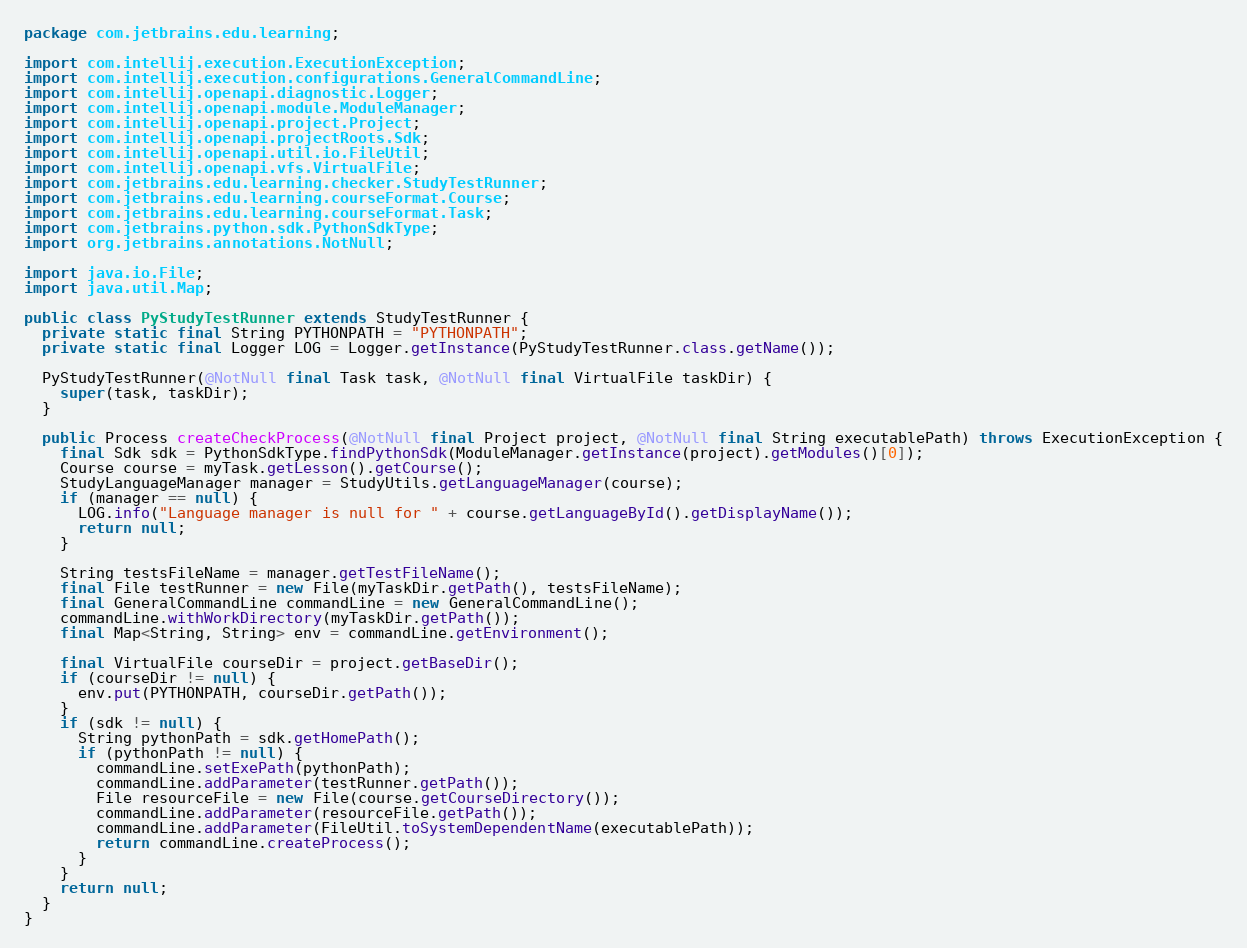<code> <loc_0><loc_0><loc_500><loc_500><_Java_>package com.jetbrains.edu.learning;

import com.intellij.execution.ExecutionException;
import com.intellij.execution.configurations.GeneralCommandLine;
import com.intellij.openapi.diagnostic.Logger;
import com.intellij.openapi.module.ModuleManager;
import com.intellij.openapi.project.Project;
import com.intellij.openapi.projectRoots.Sdk;
import com.intellij.openapi.util.io.FileUtil;
import com.intellij.openapi.vfs.VirtualFile;
import com.jetbrains.edu.learning.checker.StudyTestRunner;
import com.jetbrains.edu.learning.courseFormat.Course;
import com.jetbrains.edu.learning.courseFormat.Task;
import com.jetbrains.python.sdk.PythonSdkType;
import org.jetbrains.annotations.NotNull;

import java.io.File;
import java.util.Map;

public class PyStudyTestRunner extends StudyTestRunner {
  private static final String PYTHONPATH = "PYTHONPATH";
  private static final Logger LOG = Logger.getInstance(PyStudyTestRunner.class.getName());

  PyStudyTestRunner(@NotNull final Task task, @NotNull final VirtualFile taskDir) {
    super(task, taskDir);
  }

  public Process createCheckProcess(@NotNull final Project project, @NotNull final String executablePath) throws ExecutionException {
    final Sdk sdk = PythonSdkType.findPythonSdk(ModuleManager.getInstance(project).getModules()[0]);
    Course course = myTask.getLesson().getCourse();
    StudyLanguageManager manager = StudyUtils.getLanguageManager(course);
    if (manager == null) {
      LOG.info("Language manager is null for " + course.getLanguageById().getDisplayName());
      return null;
    }

    String testsFileName = manager.getTestFileName();
    final File testRunner = new File(myTaskDir.getPath(), testsFileName);
    final GeneralCommandLine commandLine = new GeneralCommandLine();
    commandLine.withWorkDirectory(myTaskDir.getPath());
    final Map<String, String> env = commandLine.getEnvironment();

    final VirtualFile courseDir = project.getBaseDir();
    if (courseDir != null) {
      env.put(PYTHONPATH, courseDir.getPath());
    }
    if (sdk != null) {
      String pythonPath = sdk.getHomePath();
      if (pythonPath != null) {
        commandLine.setExePath(pythonPath);
        commandLine.addParameter(testRunner.getPath());
        File resourceFile = new File(course.getCourseDirectory());
        commandLine.addParameter(resourceFile.getPath());
        commandLine.addParameter(FileUtil.toSystemDependentName(executablePath));
        return commandLine.createProcess();
      }
    }
    return null;
  }
}
</code> 